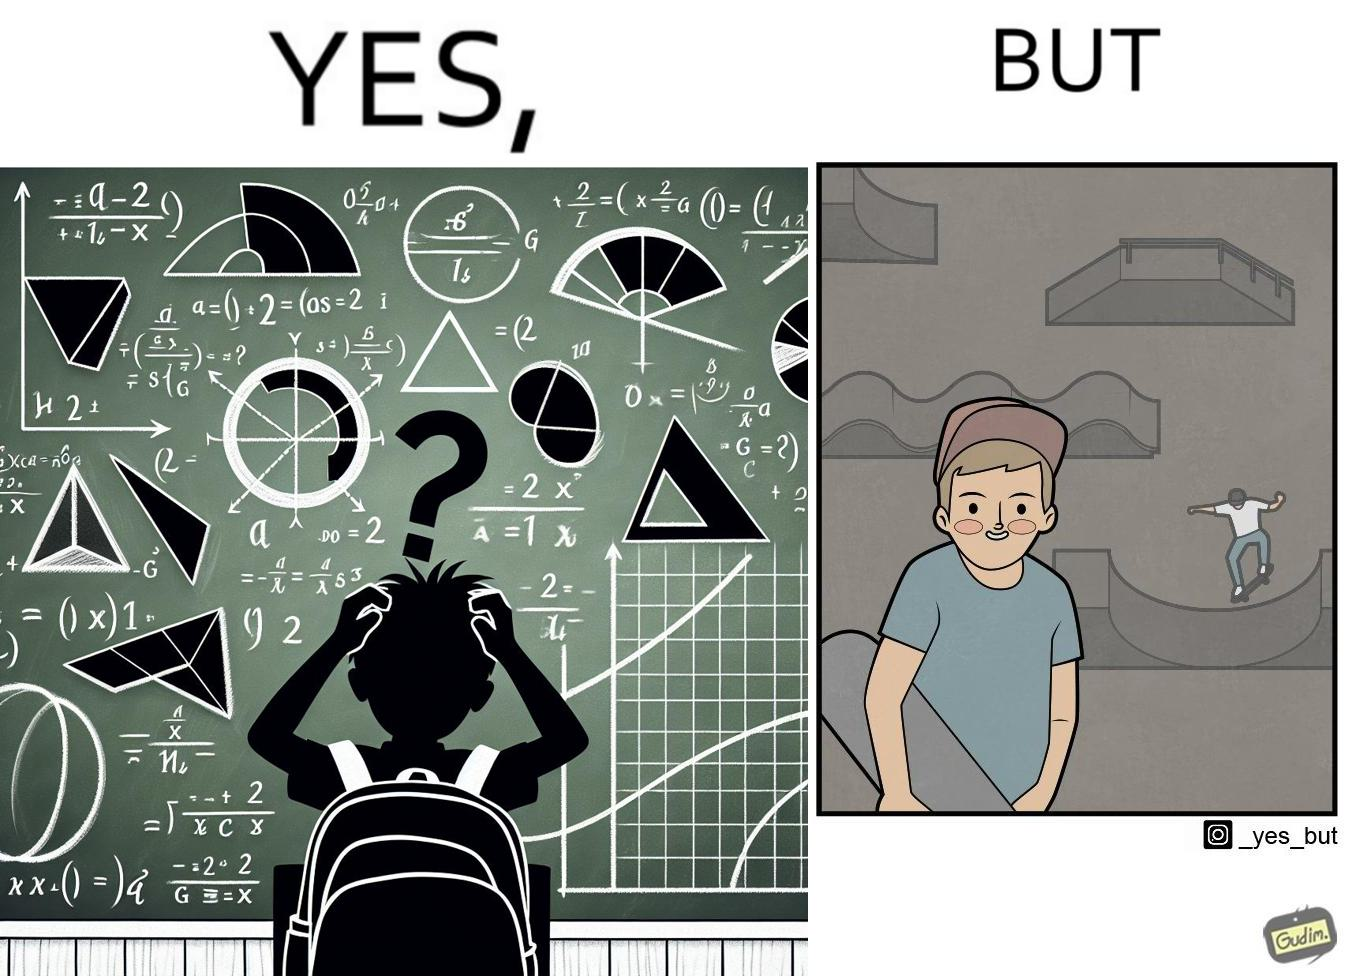Is there satirical content in this image? Yes, this image is satirical. 